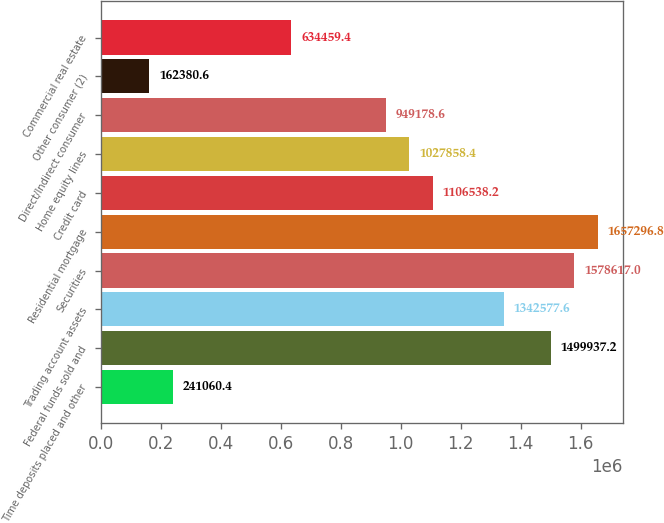Convert chart. <chart><loc_0><loc_0><loc_500><loc_500><bar_chart><fcel>Time deposits placed and other<fcel>Federal funds sold and<fcel>Trading account assets<fcel>Securities<fcel>Residential mortgage<fcel>Credit card<fcel>Home equity lines<fcel>Direct/Indirect consumer<fcel>Other consumer (2)<fcel>Commercial real estate<nl><fcel>241060<fcel>1.49994e+06<fcel>1.34258e+06<fcel>1.57862e+06<fcel>1.6573e+06<fcel>1.10654e+06<fcel>1.02786e+06<fcel>949179<fcel>162381<fcel>634459<nl></chart> 